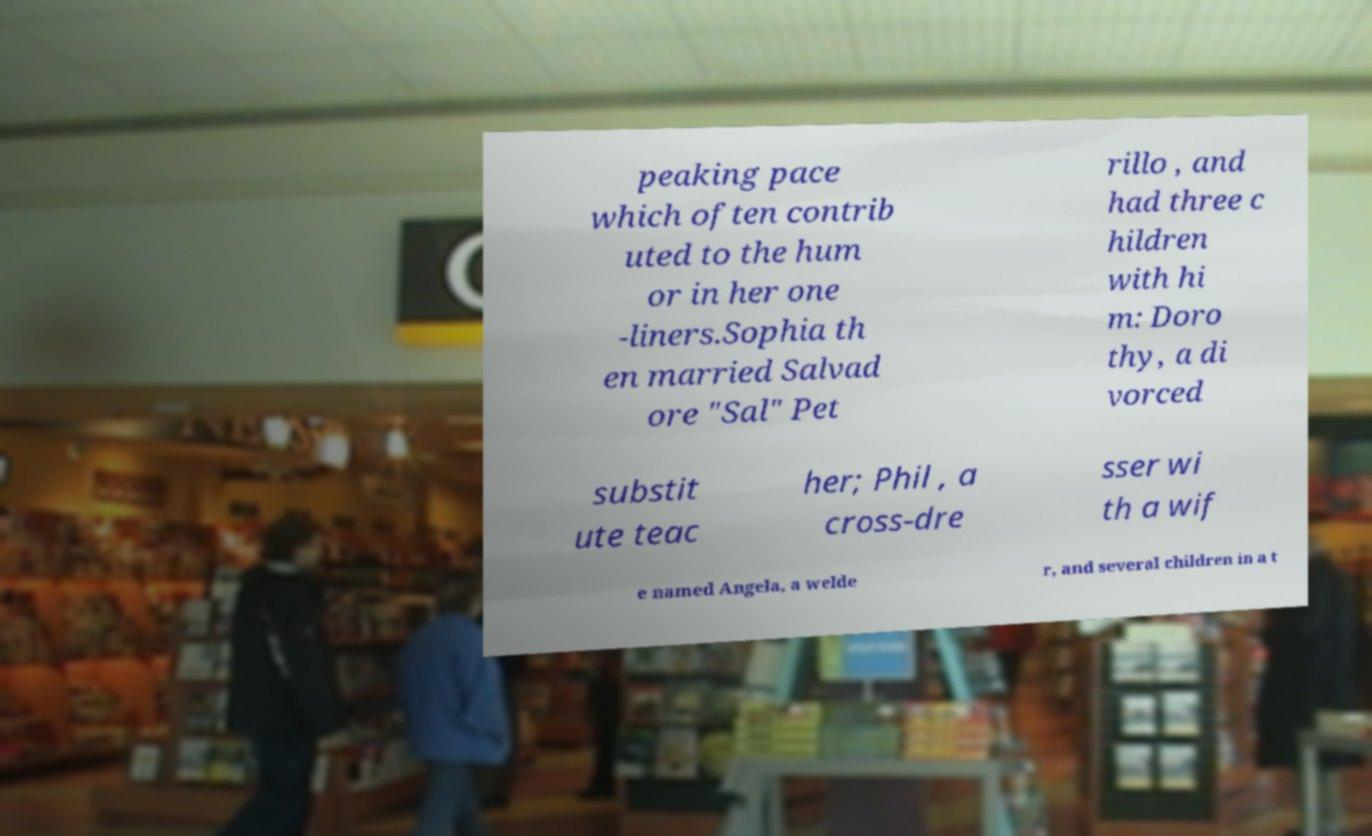Please identify and transcribe the text found in this image. peaking pace which often contrib uted to the hum or in her one -liners.Sophia th en married Salvad ore "Sal" Pet rillo , and had three c hildren with hi m: Doro thy, a di vorced substit ute teac her; Phil , a cross-dre sser wi th a wif e named Angela, a welde r, and several children in a t 